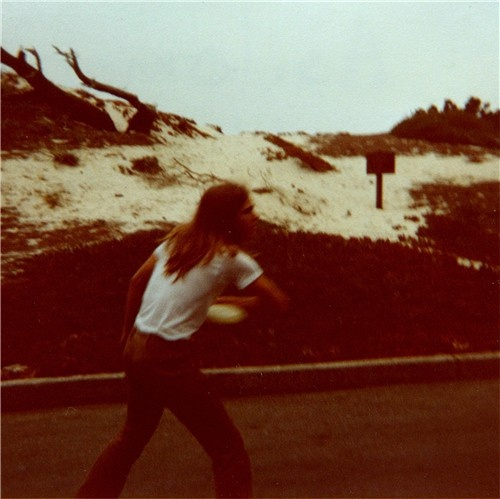Describe the objects in this image and their specific colors. I can see people in ivory, maroon, and darkgray tones and frisbee in ivory, olive, and maroon tones in this image. 